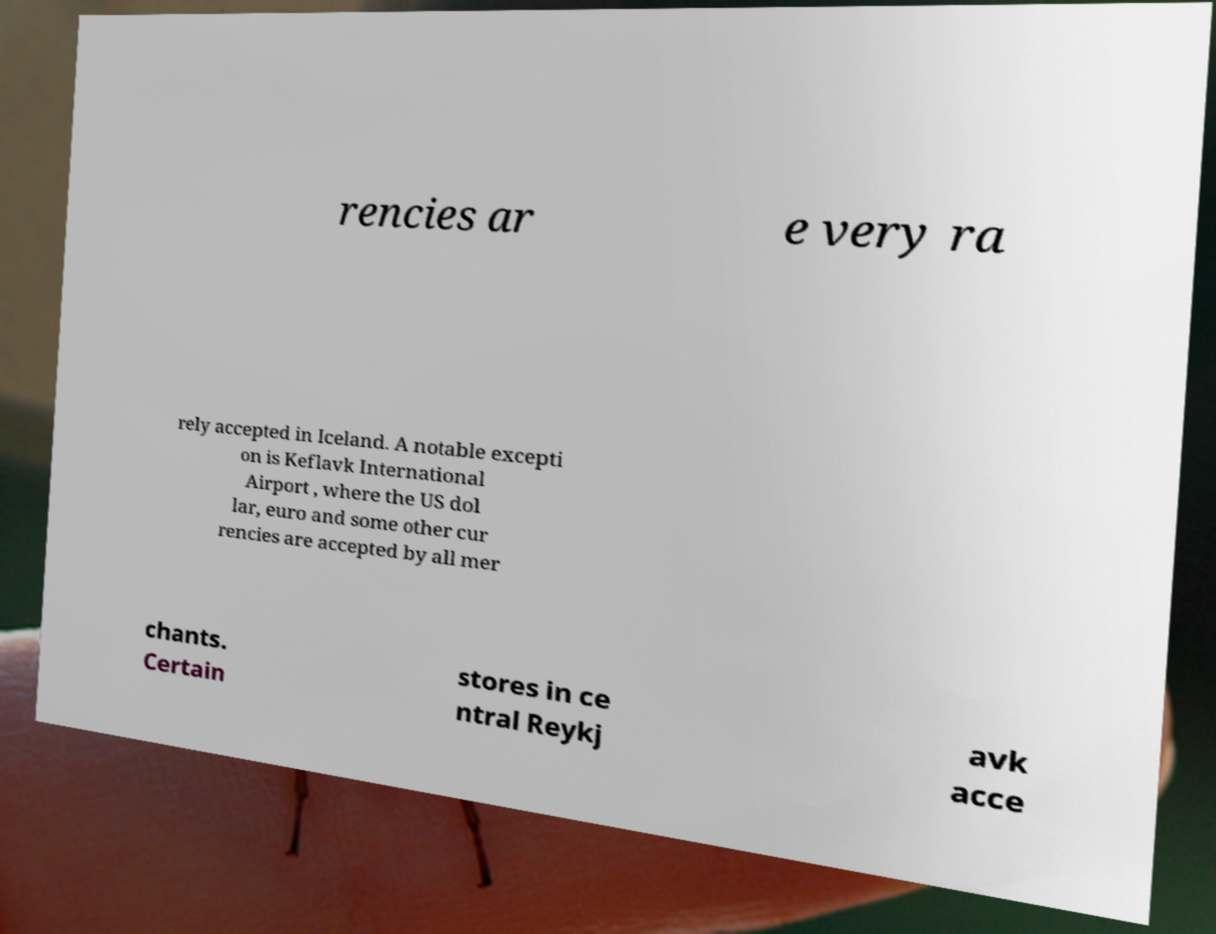Can you read and provide the text displayed in the image?This photo seems to have some interesting text. Can you extract and type it out for me? rencies ar e very ra rely accepted in Iceland. A notable excepti on is Keflavk International Airport , where the US dol lar, euro and some other cur rencies are accepted by all mer chants. Certain stores in ce ntral Reykj avk acce 